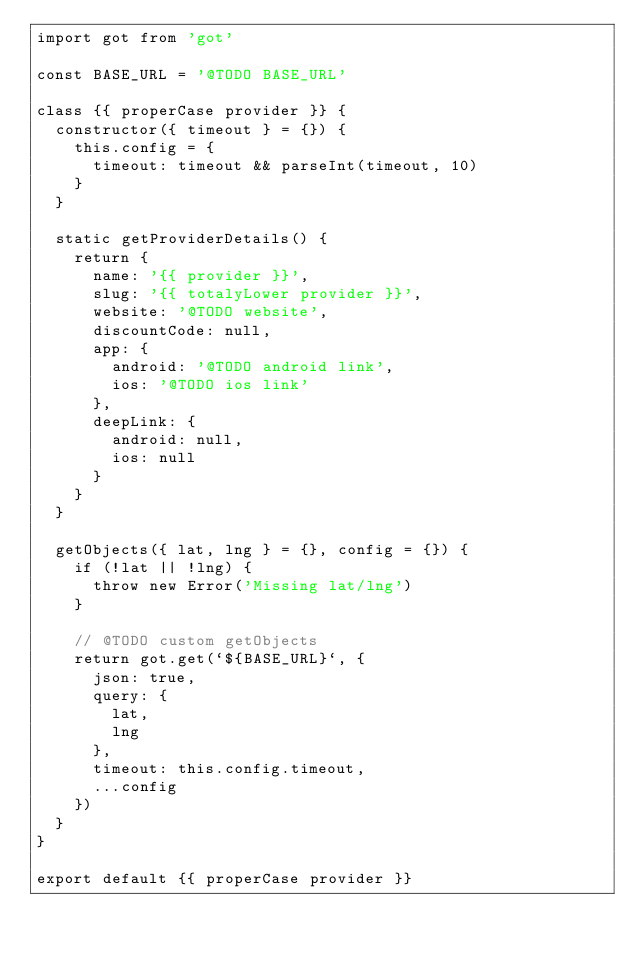<code> <loc_0><loc_0><loc_500><loc_500><_JavaScript_>import got from 'got'

const BASE_URL = '@TODO BASE_URL'

class {{ properCase provider }} {
  constructor({ timeout } = {}) {
    this.config = {
      timeout: timeout && parseInt(timeout, 10)
    }
  }

  static getProviderDetails() {
    return {
      name: '{{ provider }}',
      slug: '{{ totalyLower provider }}',
      website: '@TODO website',
      discountCode: null,
      app: {
        android: '@TODO android link',
        ios: '@TODO ios link'
      },
      deepLink: {
        android: null,
        ios: null
      }
    }
  }

  getObjects({ lat, lng } = {}, config = {}) {
    if (!lat || !lng) {
      throw new Error('Missing lat/lng')
    }

    // @TODO custom getObjects
    return got.get(`${BASE_URL}`, {
      json: true,
      query: {
        lat,
        lng
      },
      timeout: this.config.timeout,
      ...config
    })
  }
}

export default {{ properCase provider }}
</code> 